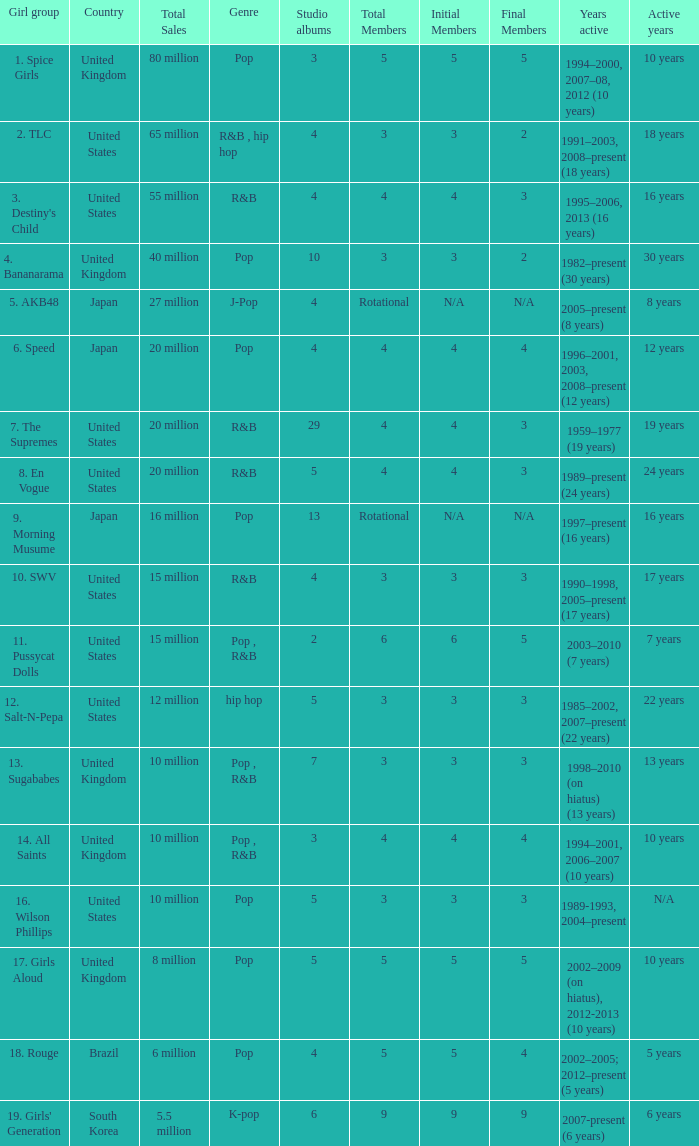Which group produced 29 studio albums? 7. The Supremes. 